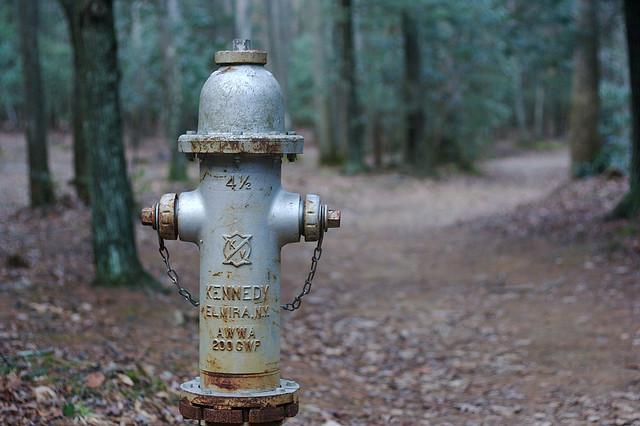Is the fire hydrant in the middle of a forest?
Answer briefly. Yes. Which presidential last name is on the fire hydrant?
Short answer required. Kennedy. What color is the paint on this fire hydrant?
Concise answer only. Silver. What color is the hydrant?
Answer briefly. Gray. 